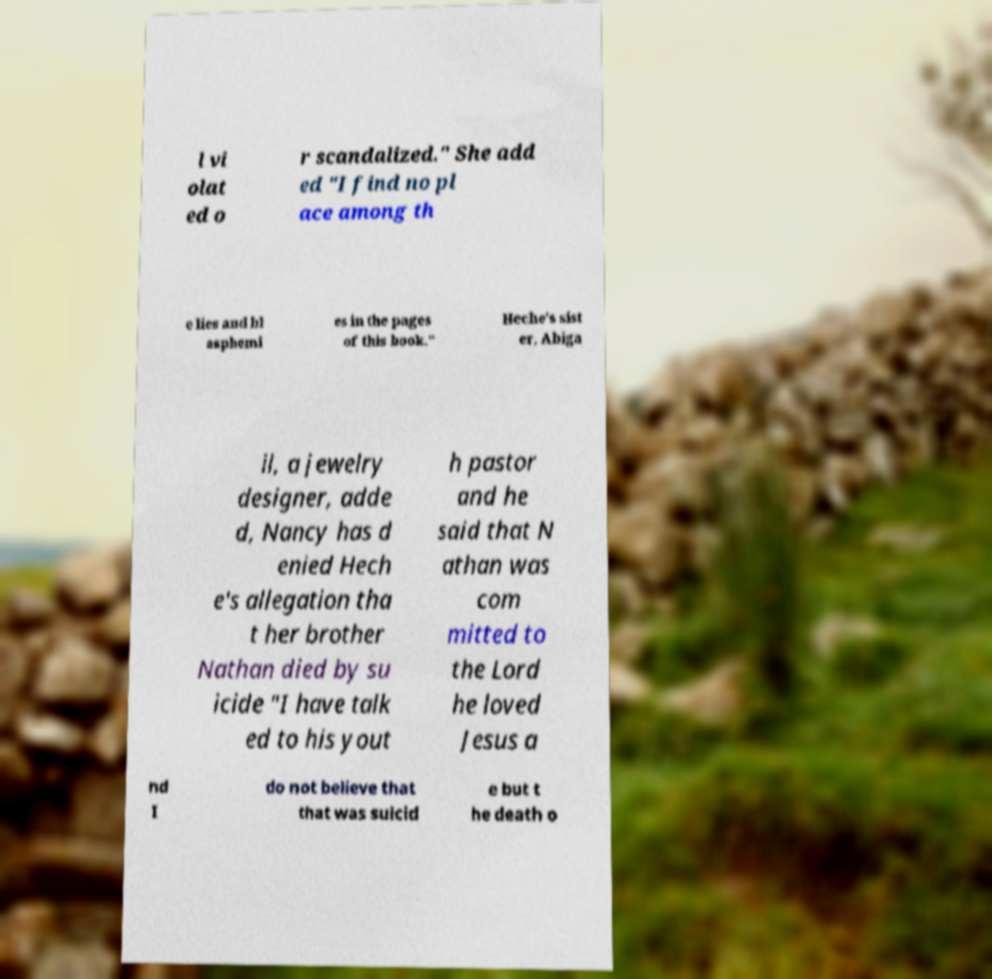I need the written content from this picture converted into text. Can you do that? l vi olat ed o r scandalized." She add ed "I find no pl ace among th e lies and bl asphemi es in the pages of this book." Heche's sist er, Abiga il, a jewelry designer, adde d, Nancy has d enied Hech e's allegation tha t her brother Nathan died by su icide "I have talk ed to his yout h pastor and he said that N athan was com mitted to the Lord he loved Jesus a nd I do not believe that that was suicid e but t he death o 